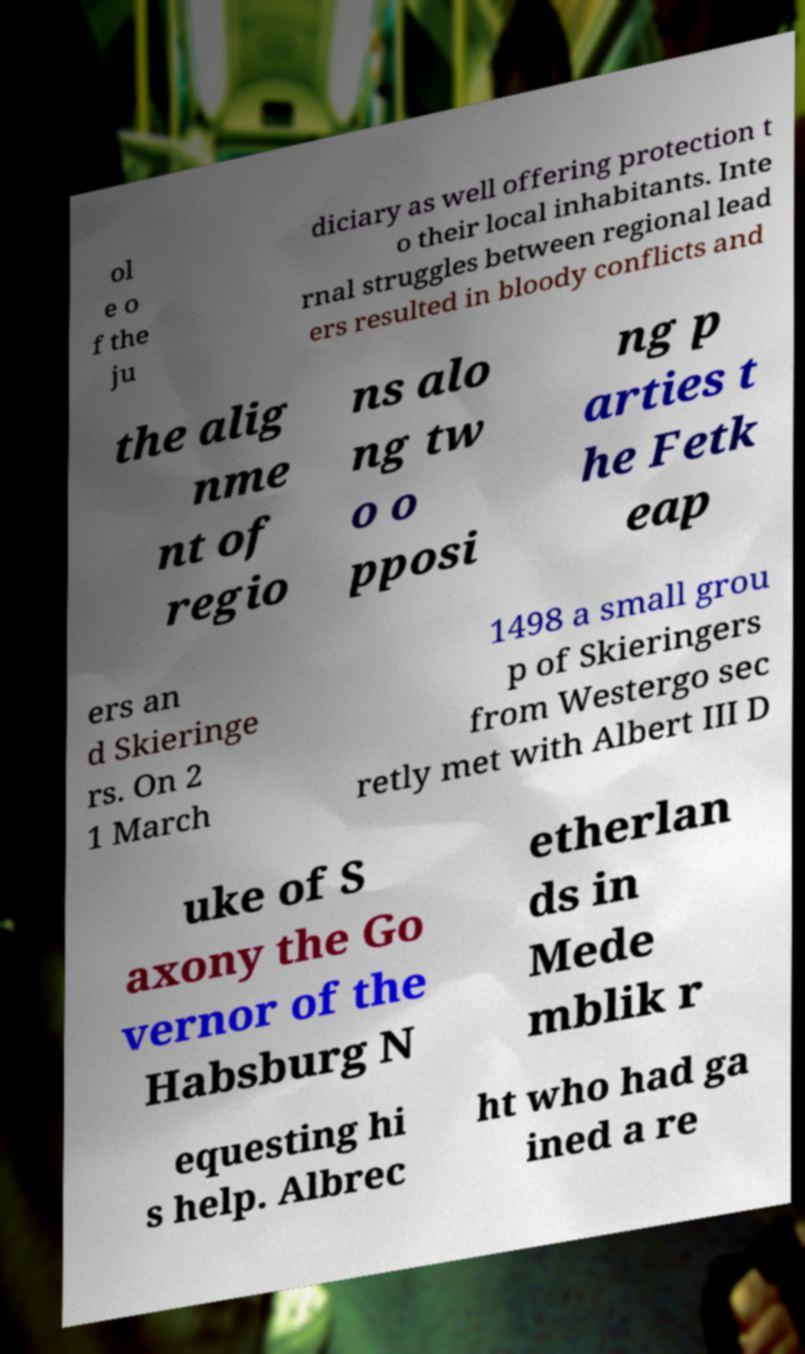Could you extract and type out the text from this image? ol e o f the ju diciary as well offering protection t o their local inhabitants. Inte rnal struggles between regional lead ers resulted in bloody conflicts and the alig nme nt of regio ns alo ng tw o o pposi ng p arties t he Fetk eap ers an d Skieringe rs. On 2 1 March 1498 a small grou p of Skieringers from Westergo sec retly met with Albert III D uke of S axony the Go vernor of the Habsburg N etherlan ds in Mede mblik r equesting hi s help. Albrec ht who had ga ined a re 